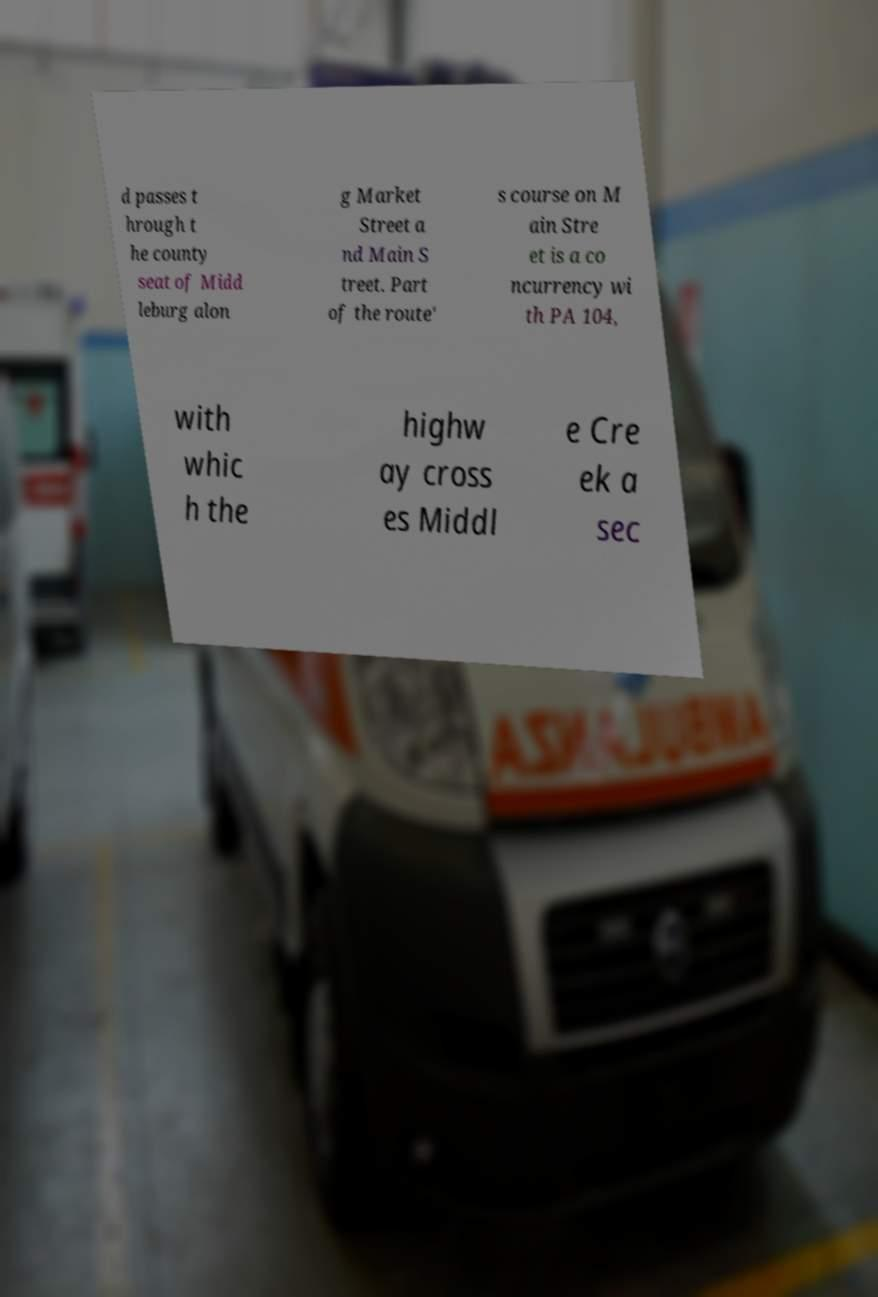There's text embedded in this image that I need extracted. Can you transcribe it verbatim? d passes t hrough t he county seat of Midd leburg alon g Market Street a nd Main S treet. Part of the route' s course on M ain Stre et is a co ncurrency wi th PA 104, with whic h the highw ay cross es Middl e Cre ek a sec 